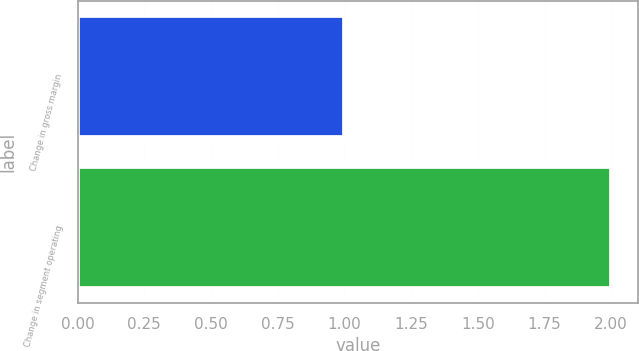Convert chart. <chart><loc_0><loc_0><loc_500><loc_500><bar_chart><fcel>Change in gross margin<fcel>Change in segment operating<nl><fcel>1<fcel>2<nl></chart> 